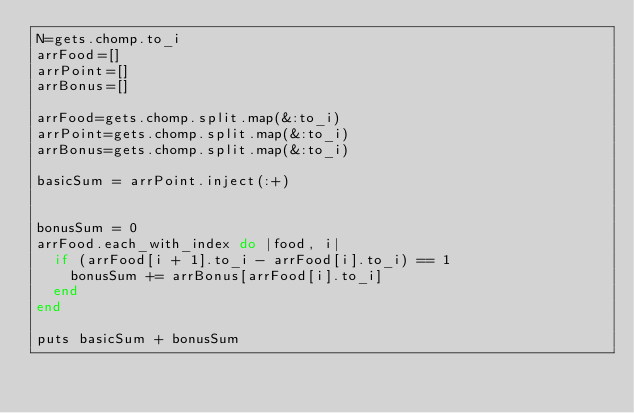<code> <loc_0><loc_0><loc_500><loc_500><_Ruby_>N=gets.chomp.to_i
arrFood=[]
arrPoint=[]
arrBonus=[]

arrFood=gets.chomp.split.map(&:to_i)
arrPoint=gets.chomp.split.map(&:to_i)
arrBonus=gets.chomp.split.map(&:to_i)

basicSum = arrPoint.inject(:+)


bonusSum = 0
arrFood.each_with_index do |food, i|
  if (arrFood[i + 1].to_i - arrFood[i].to_i) == 1
    bonusSum += arrBonus[arrFood[i].to_i]
  end
end

puts basicSum + bonusSum</code> 